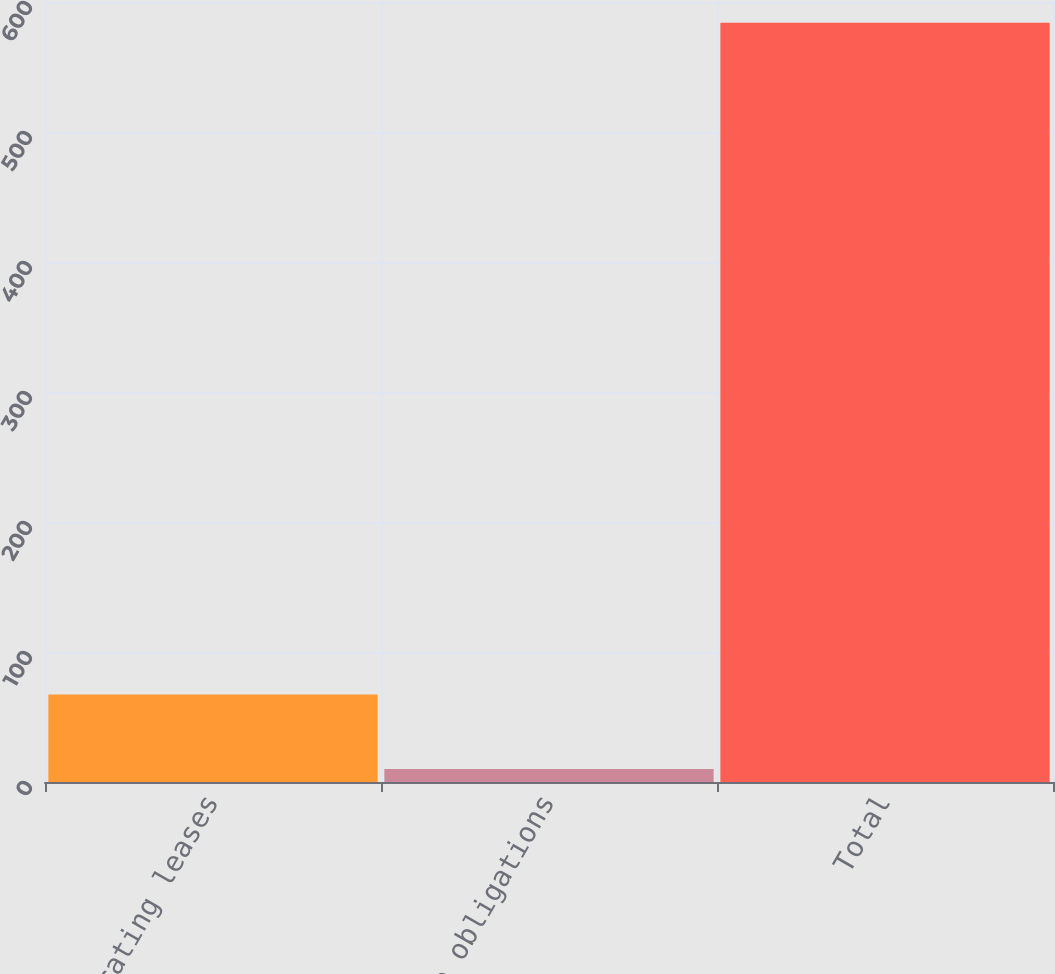<chart> <loc_0><loc_0><loc_500><loc_500><bar_chart><fcel>Operating leases<fcel>Purchase obligations<fcel>Total<nl><fcel>67.4<fcel>10<fcel>584<nl></chart> 